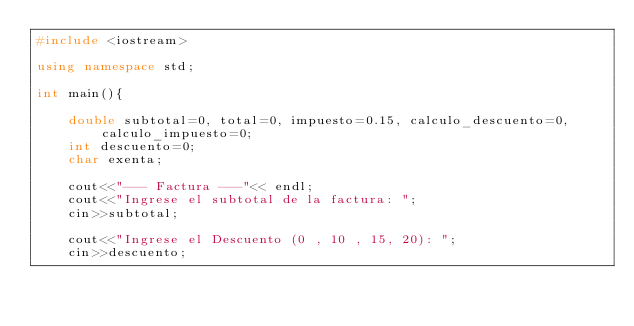<code> <loc_0><loc_0><loc_500><loc_500><_C++_>#include <iostream>

using namespace std;

int main(){

    double subtotal=0, total=0, impuesto=0.15, calculo_descuento=0, calculo_impuesto=0;
    int descuento=0;
    char exenta;
    
    cout<<"--- Factura ---"<< endl;
    cout<<"Ingrese el subtotal de la factura: ";
    cin>>subtotal;

    cout<<"Ingrese el Descuento (0 , 10 , 15, 20): ";
    cin>>descuento;
    </code> 